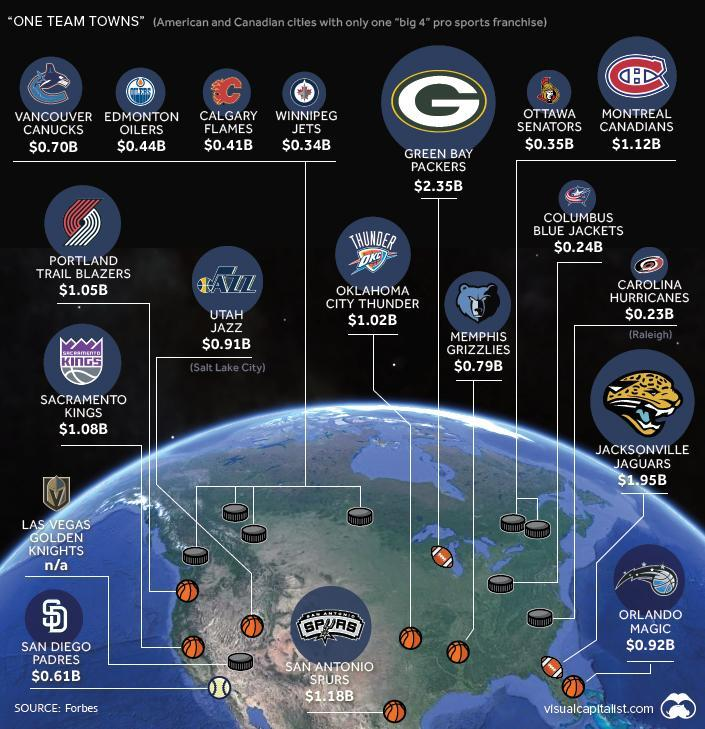What is written inside the logo of Oklahoma City Thunder
Answer the question with a short phrase. Thunder DKC What is the total value of Portland Trail Blazers and Utaj Jazz in Billion 1.96 What is the value of columbus blue jackets $0.24B 